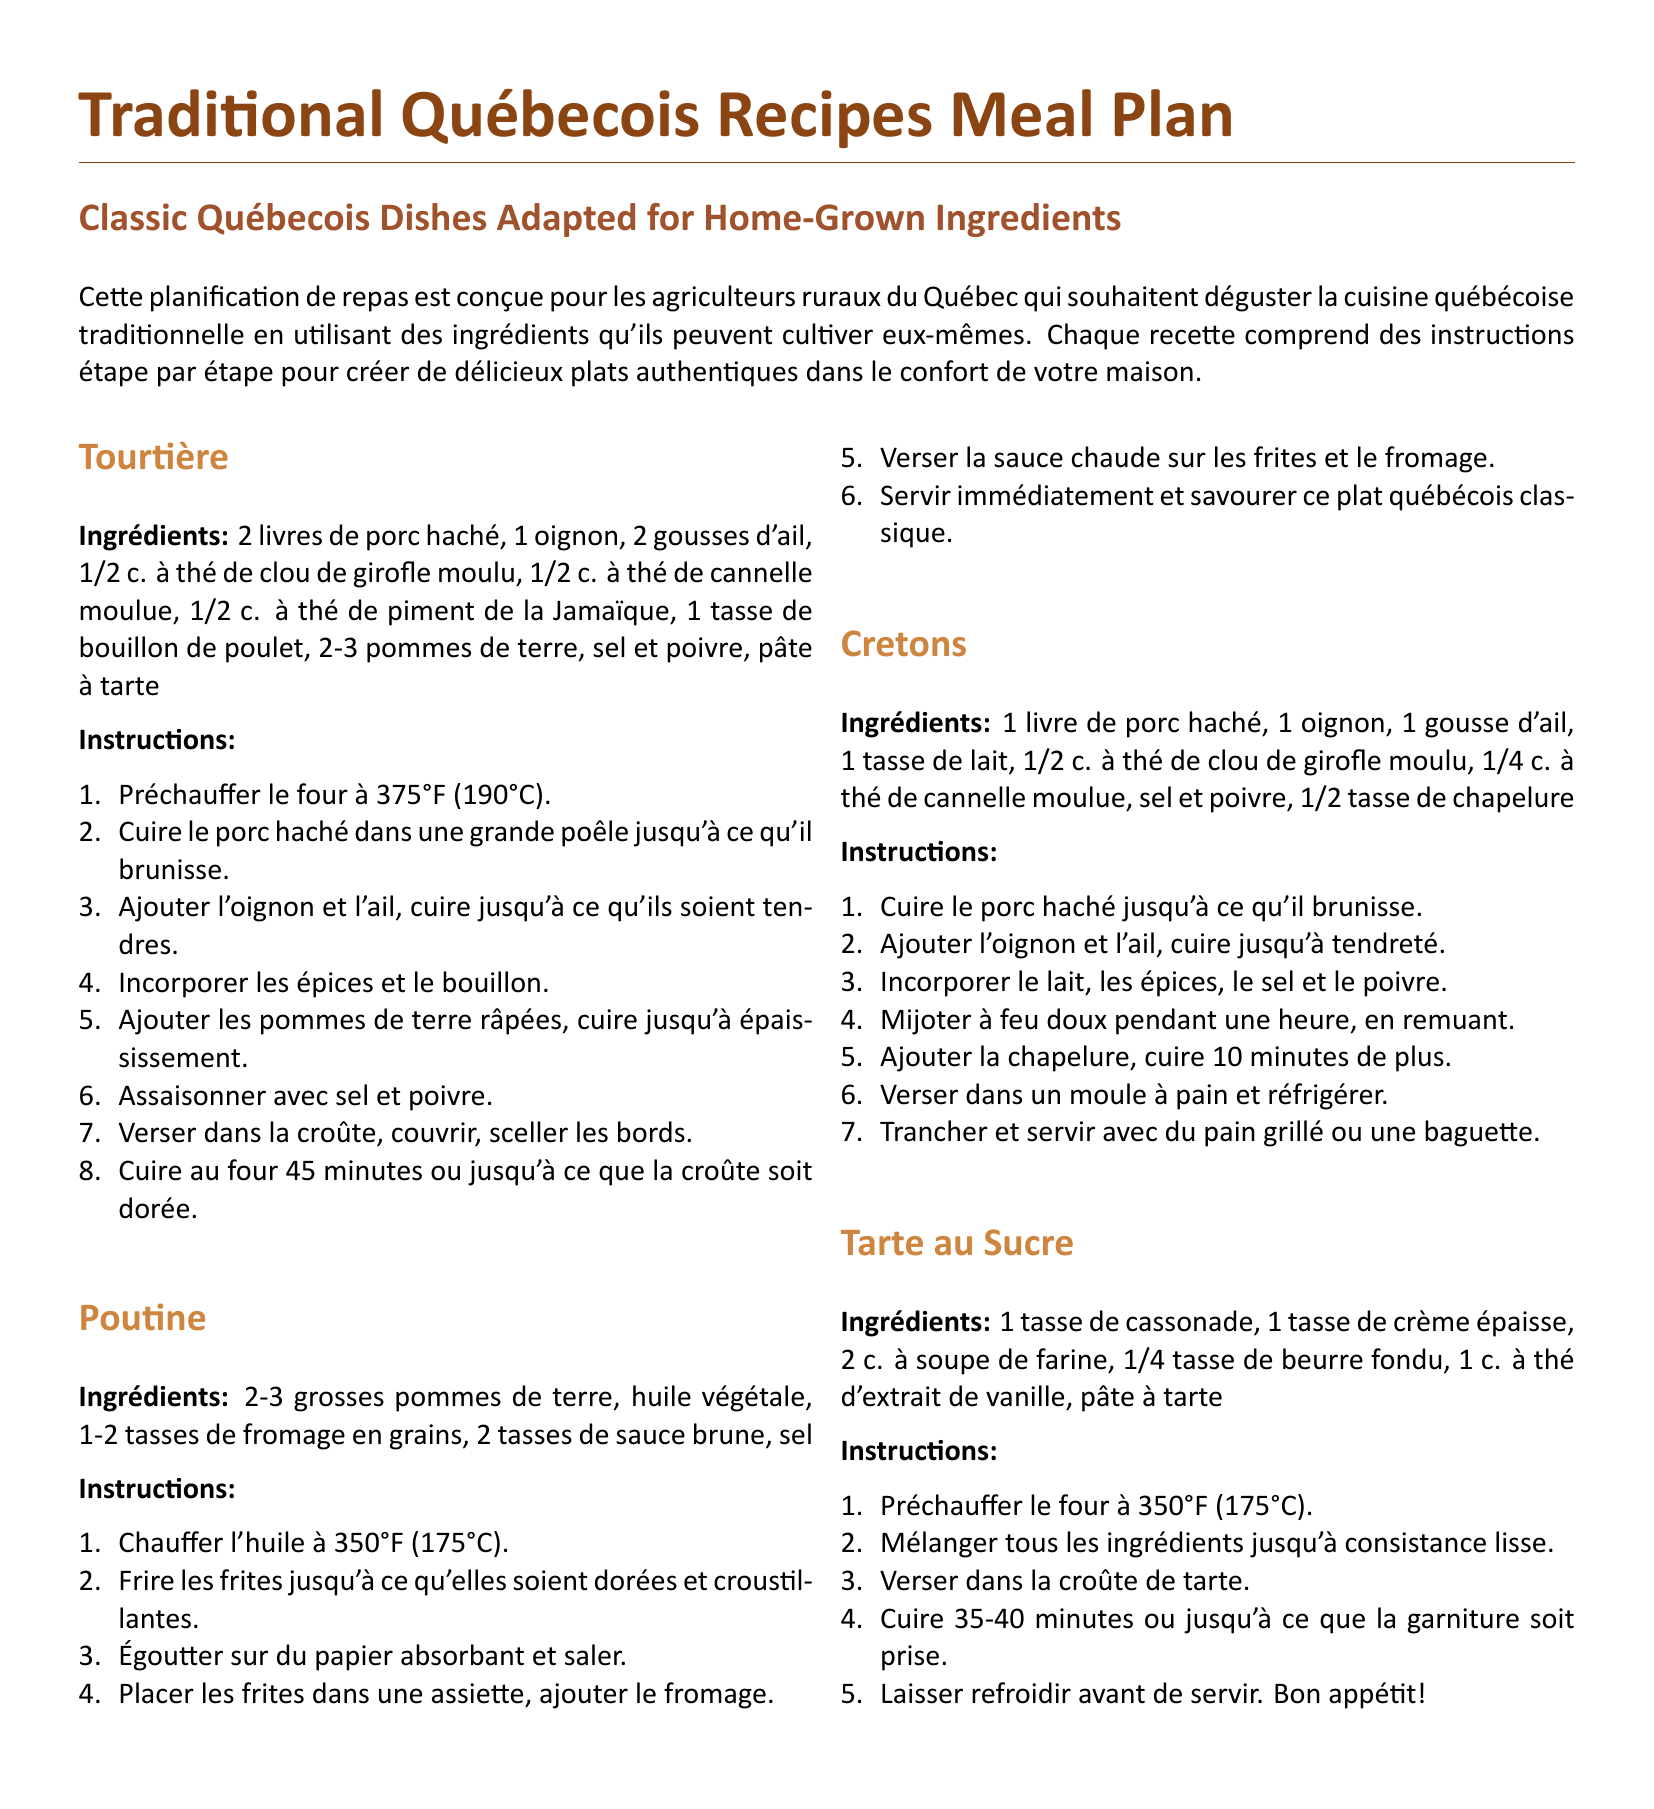Quel est l'ingrédient principal de la tourtière ? L'ingrédient principal est 2 livres de porc haché.
Answer: 2 livres de porc haché À quelle température doit-on préchauffer le four pour la tarte au sucre ? La température de préchauffage du four pour la tarte au sucre est de 350°F (175°C).
Answer: 350°F (175°C) Combien de pommes de terre sont nécessaires pour faire la poutine ? La recette de poutine nécessite 2-3 grosses pommes de terre.
Answer: 2-3 grosses pommes de terre Combien de minutes faut-il cuire la tourtière au four ? La tourtière doit cuire au four pendant 45 minutes.
Answer: 45 minutes Quel est un des ingrédients des cretons ? Un des ingrédients des cretons est 1 livre de porc haché.
Answer: 1 livre de porc haché Quelles épices sont utilisées dans la tourtière ? Les épices utilisées dans la tourtière sont le clou de girofle, la cannelle et le piment de la Jamaïque.
Answer: Clou de girofle, cannelle, piment de la Jamaïque Quelle est la dernière étape pour préparer la tarte au sucre ? La dernière étape consiste à laisser refroidir avant de servir.
Answer: Laisser refroidir avant de servir Combien de tasses de fromage en grains sont nécessaires pour la poutine ? Il faut 1-2 tasses de fromage en grains pour la poutine.
Answer: 1-2 tasses de fromage en grains Quel est le type de plat que les recettes de ce document représentent ? Les recettes de ce document représentent des plats québécois traditionnels.
Answer: Plats québécois traditionnels 